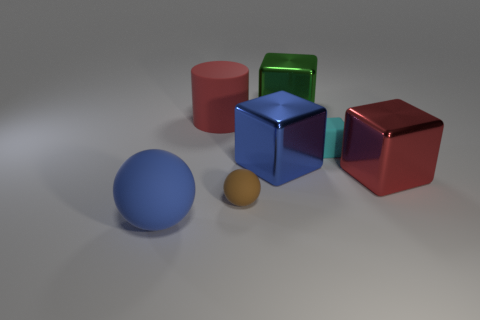Subtract all large green cubes. How many cubes are left? 3 Add 3 large blue matte things. How many objects exist? 10 Subtract 1 blocks. How many blocks are left? 3 Subtract all cyan blocks. How many blocks are left? 3 Subtract all spheres. How many objects are left? 5 Subtract 0 blue cylinders. How many objects are left? 7 Subtract all blue balls. Subtract all purple cylinders. How many balls are left? 1 Subtract all purple balls. How many red cubes are left? 1 Subtract all small rubber blocks. Subtract all small cyan rubber cubes. How many objects are left? 5 Add 5 red blocks. How many red blocks are left? 6 